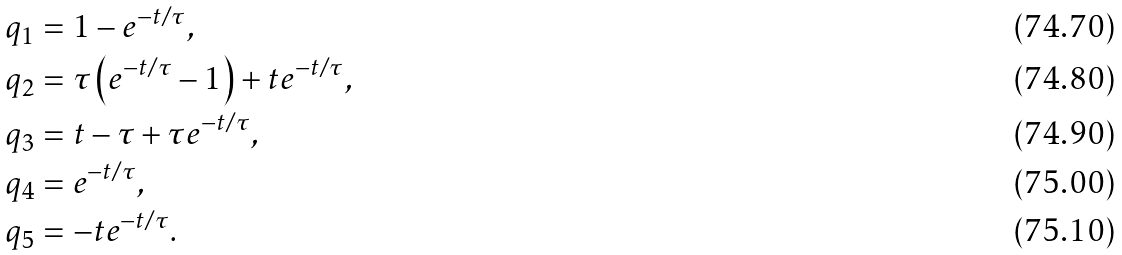<formula> <loc_0><loc_0><loc_500><loc_500>q _ { 1 } & = 1 - e ^ { - t / \tau } , \\ q _ { 2 } & = \tau \left ( e ^ { - t / \tau } - 1 \right ) + t e ^ { - t / \tau } , \\ q _ { 3 } & = t - \tau + \tau e ^ { - t / \tau } , \\ q _ { 4 } & = e ^ { - t / \tau } , \\ q _ { 5 } & = - t e ^ { - t / \tau } .</formula> 